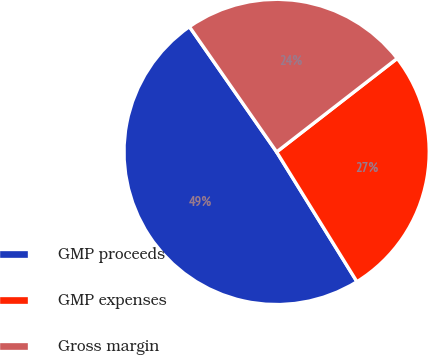Convert chart to OTSL. <chart><loc_0><loc_0><loc_500><loc_500><pie_chart><fcel>GMP proceeds<fcel>GMP expenses<fcel>Gross margin<nl><fcel>49.14%<fcel>26.68%<fcel>24.18%<nl></chart> 